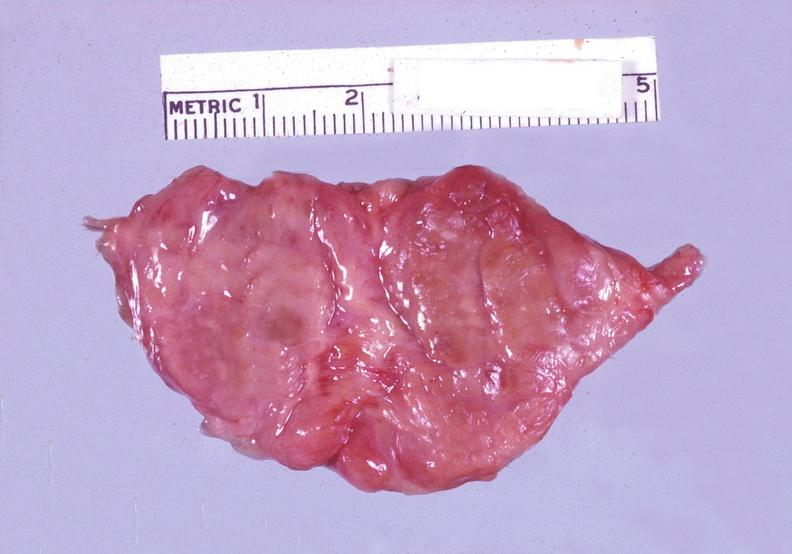does this section showing liver with tumor mass in hilar area tumor show thyroid, hashimotos?
Answer the question using a single word or phrase. No 